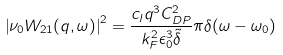<formula> <loc_0><loc_0><loc_500><loc_500>\left | \nu _ { 0 } W _ { 2 1 } ( q , \omega ) \right | ^ { 2 } = \frac { c _ { l } q ^ { 3 } C _ { D P } ^ { 2 } } { k _ { F } ^ { 2 } \epsilon _ { 0 } ^ { 3 } \tilde { \delta } } \pi \delta ( \omega - \omega _ { 0 } )</formula> 